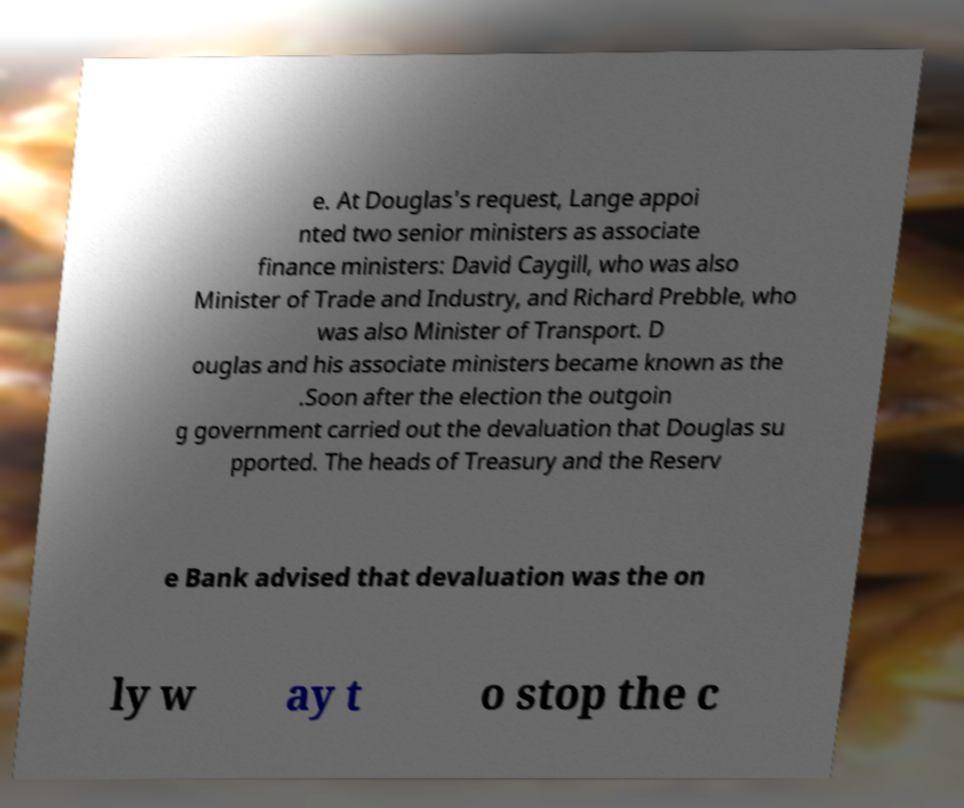Can you read and provide the text displayed in the image?This photo seems to have some interesting text. Can you extract and type it out for me? e. At Douglas's request, Lange appoi nted two senior ministers as associate finance ministers: David Caygill, who was also Minister of Trade and Industry, and Richard Prebble, who was also Minister of Transport. D ouglas and his associate ministers became known as the .Soon after the election the outgoin g government carried out the devaluation that Douglas su pported. The heads of Treasury and the Reserv e Bank advised that devaluation was the on ly w ay t o stop the c 